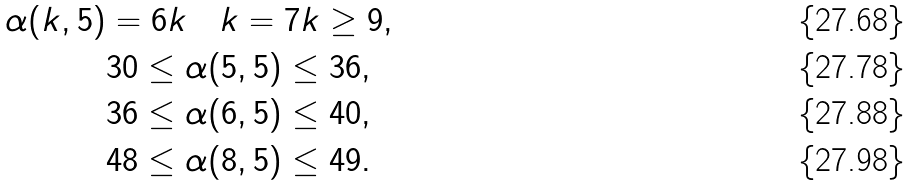<formula> <loc_0><loc_0><loc_500><loc_500>\alpha ( k , 5 ) & = 6 k \quad k = 7 k \geq 9 , \\ & 3 0 \leq \alpha ( 5 , 5 ) \leq 3 6 , \\ & 3 6 \leq \alpha ( 6 , 5 ) \leq 4 0 , \\ & 4 8 \leq \alpha ( 8 , 5 ) \leq 4 9 .</formula> 